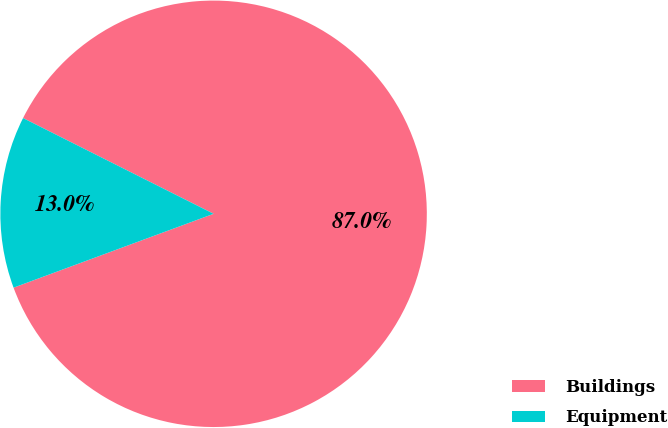Convert chart to OTSL. <chart><loc_0><loc_0><loc_500><loc_500><pie_chart><fcel>Buildings<fcel>Equipment<nl><fcel>86.96%<fcel>13.04%<nl></chart> 